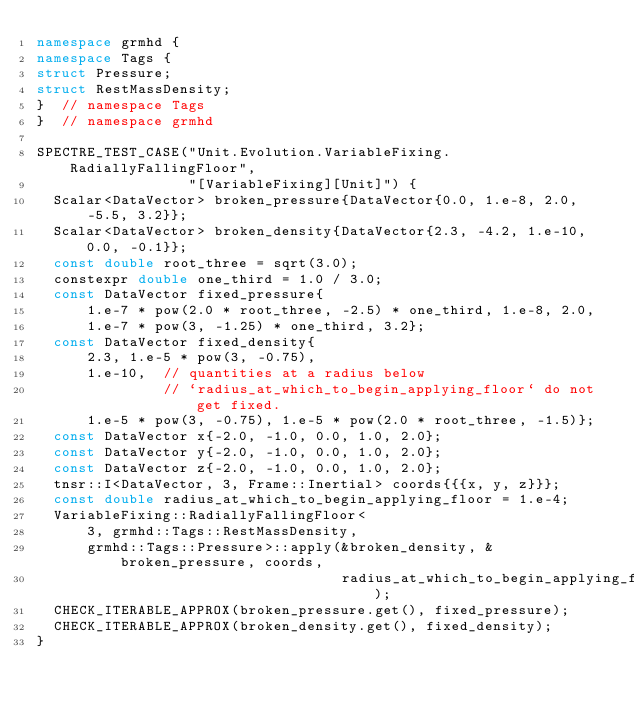Convert code to text. <code><loc_0><loc_0><loc_500><loc_500><_C++_>namespace grmhd {
namespace Tags {
struct Pressure;
struct RestMassDensity;
}  // namespace Tags
}  // namespace grmhd

SPECTRE_TEST_CASE("Unit.Evolution.VariableFixing.RadiallyFallingFloor",
                  "[VariableFixing][Unit]") {
  Scalar<DataVector> broken_pressure{DataVector{0.0, 1.e-8, 2.0, -5.5, 3.2}};
  Scalar<DataVector> broken_density{DataVector{2.3, -4.2, 1.e-10, 0.0, -0.1}};
  const double root_three = sqrt(3.0);
  constexpr double one_third = 1.0 / 3.0;
  const DataVector fixed_pressure{
      1.e-7 * pow(2.0 * root_three, -2.5) * one_third, 1.e-8, 2.0,
      1.e-7 * pow(3, -1.25) * one_third, 3.2};
  const DataVector fixed_density{
      2.3, 1.e-5 * pow(3, -0.75),
      1.e-10,  // quantities at a radius below
               // `radius_at_which_to_begin_applying_floor` do not get fixed.
      1.e-5 * pow(3, -0.75), 1.e-5 * pow(2.0 * root_three, -1.5)};
  const DataVector x{-2.0, -1.0, 0.0, 1.0, 2.0};
  const DataVector y{-2.0, -1.0, 0.0, 1.0, 2.0};
  const DataVector z{-2.0, -1.0, 0.0, 1.0, 2.0};
  tnsr::I<DataVector, 3, Frame::Inertial> coords{{{x, y, z}}};
  const double radius_at_which_to_begin_applying_floor = 1.e-4;
  VariableFixing::RadiallyFallingFloor<
      3, grmhd::Tags::RestMassDensity,
      grmhd::Tags::Pressure>::apply(&broken_density, &broken_pressure, coords,
                                    radius_at_which_to_begin_applying_floor);
  CHECK_ITERABLE_APPROX(broken_pressure.get(), fixed_pressure);
  CHECK_ITERABLE_APPROX(broken_density.get(), fixed_density);
}
</code> 